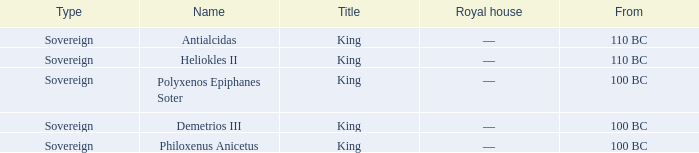When did philoxenus anicetus commence his reign? 100 BC. 